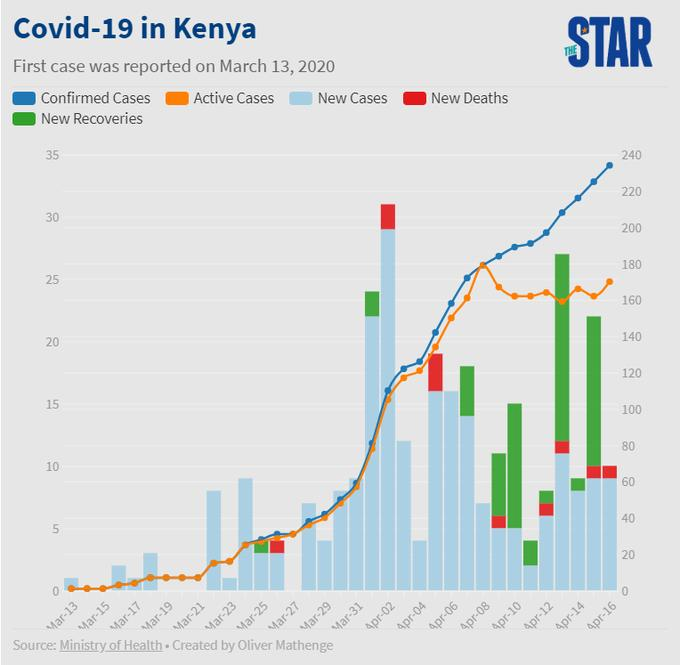Outline some significant characteristics in this image. On April 15, there were 10 new deaths. On April 16th, the total number of new cases and new deaths was 70. As of April 16, the number of new deaths is 10. There were 80 new recoveries on April 15. 